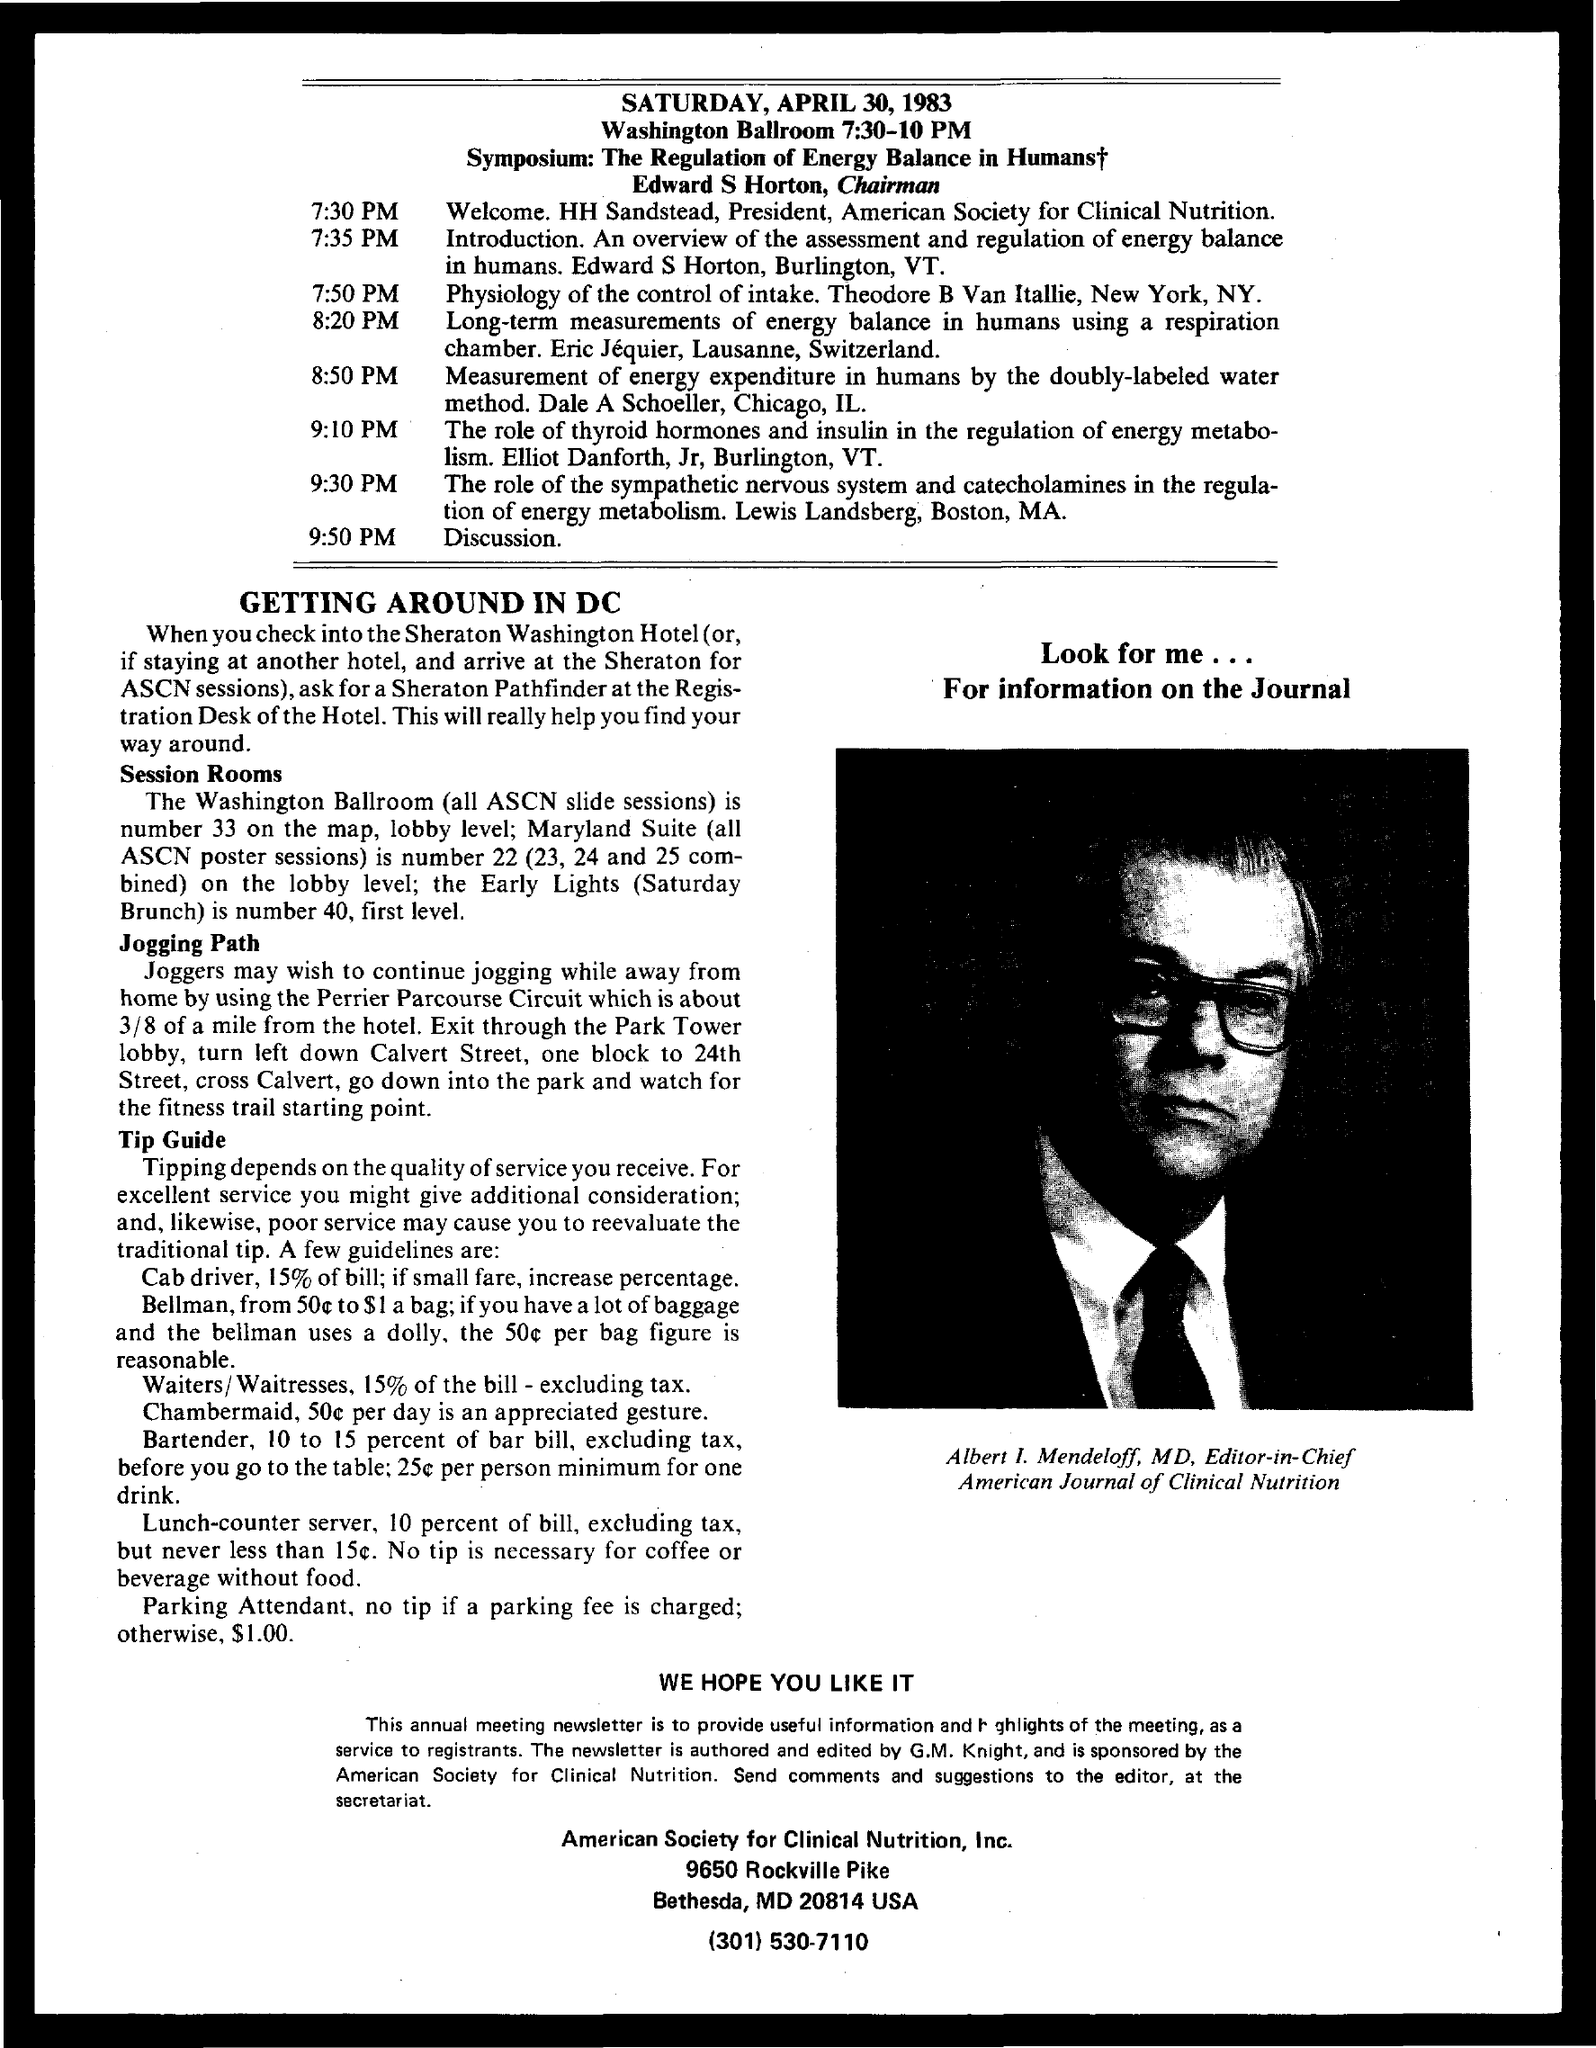Highlight a few significant elements in this photo. Albert I. Mendeloff is the Editor-in-Chief of the American Journal of Clinical Nutrition. The American Journal of Clinical Nutrition is led by Albert I. Mendeloff as its Managing Director. The Washington Ballroom number is 33. 